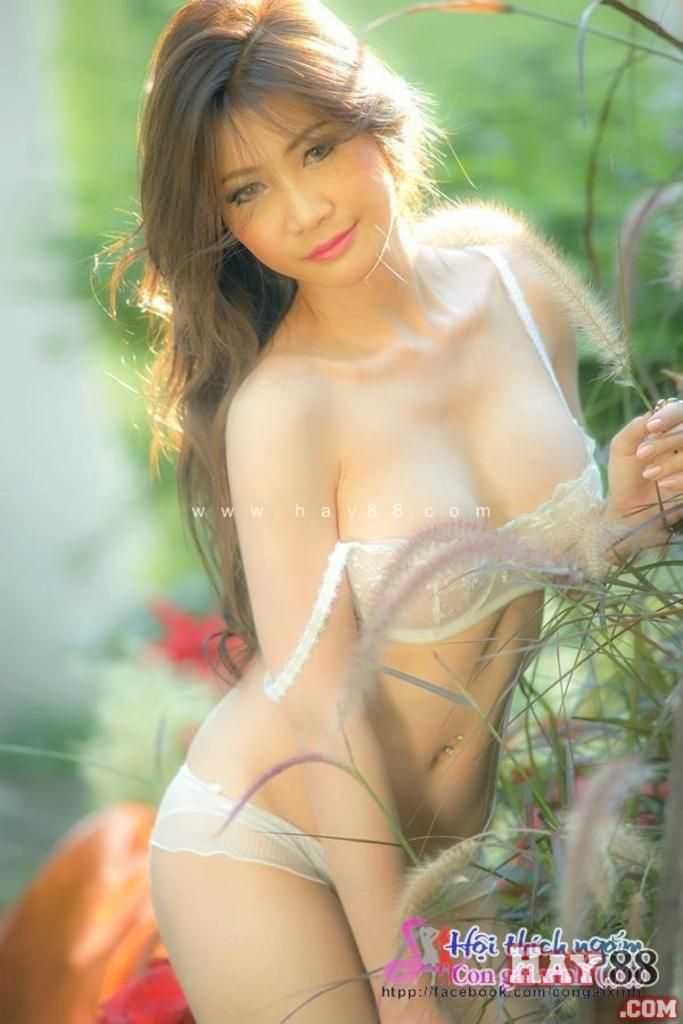Who is the main subject in the foreground of the image? There is a woman in the foreground of the image. What is the woman doing in the image? The woman is standing and holding plants. Where are additional plants located in the image? There are plants on the right side of the image. Can you describe the background of the image? The background of the image is blurred. What type of whistle can be heard in the background of the image? There is no whistle present in the image, and therefore no sound can be heard. 